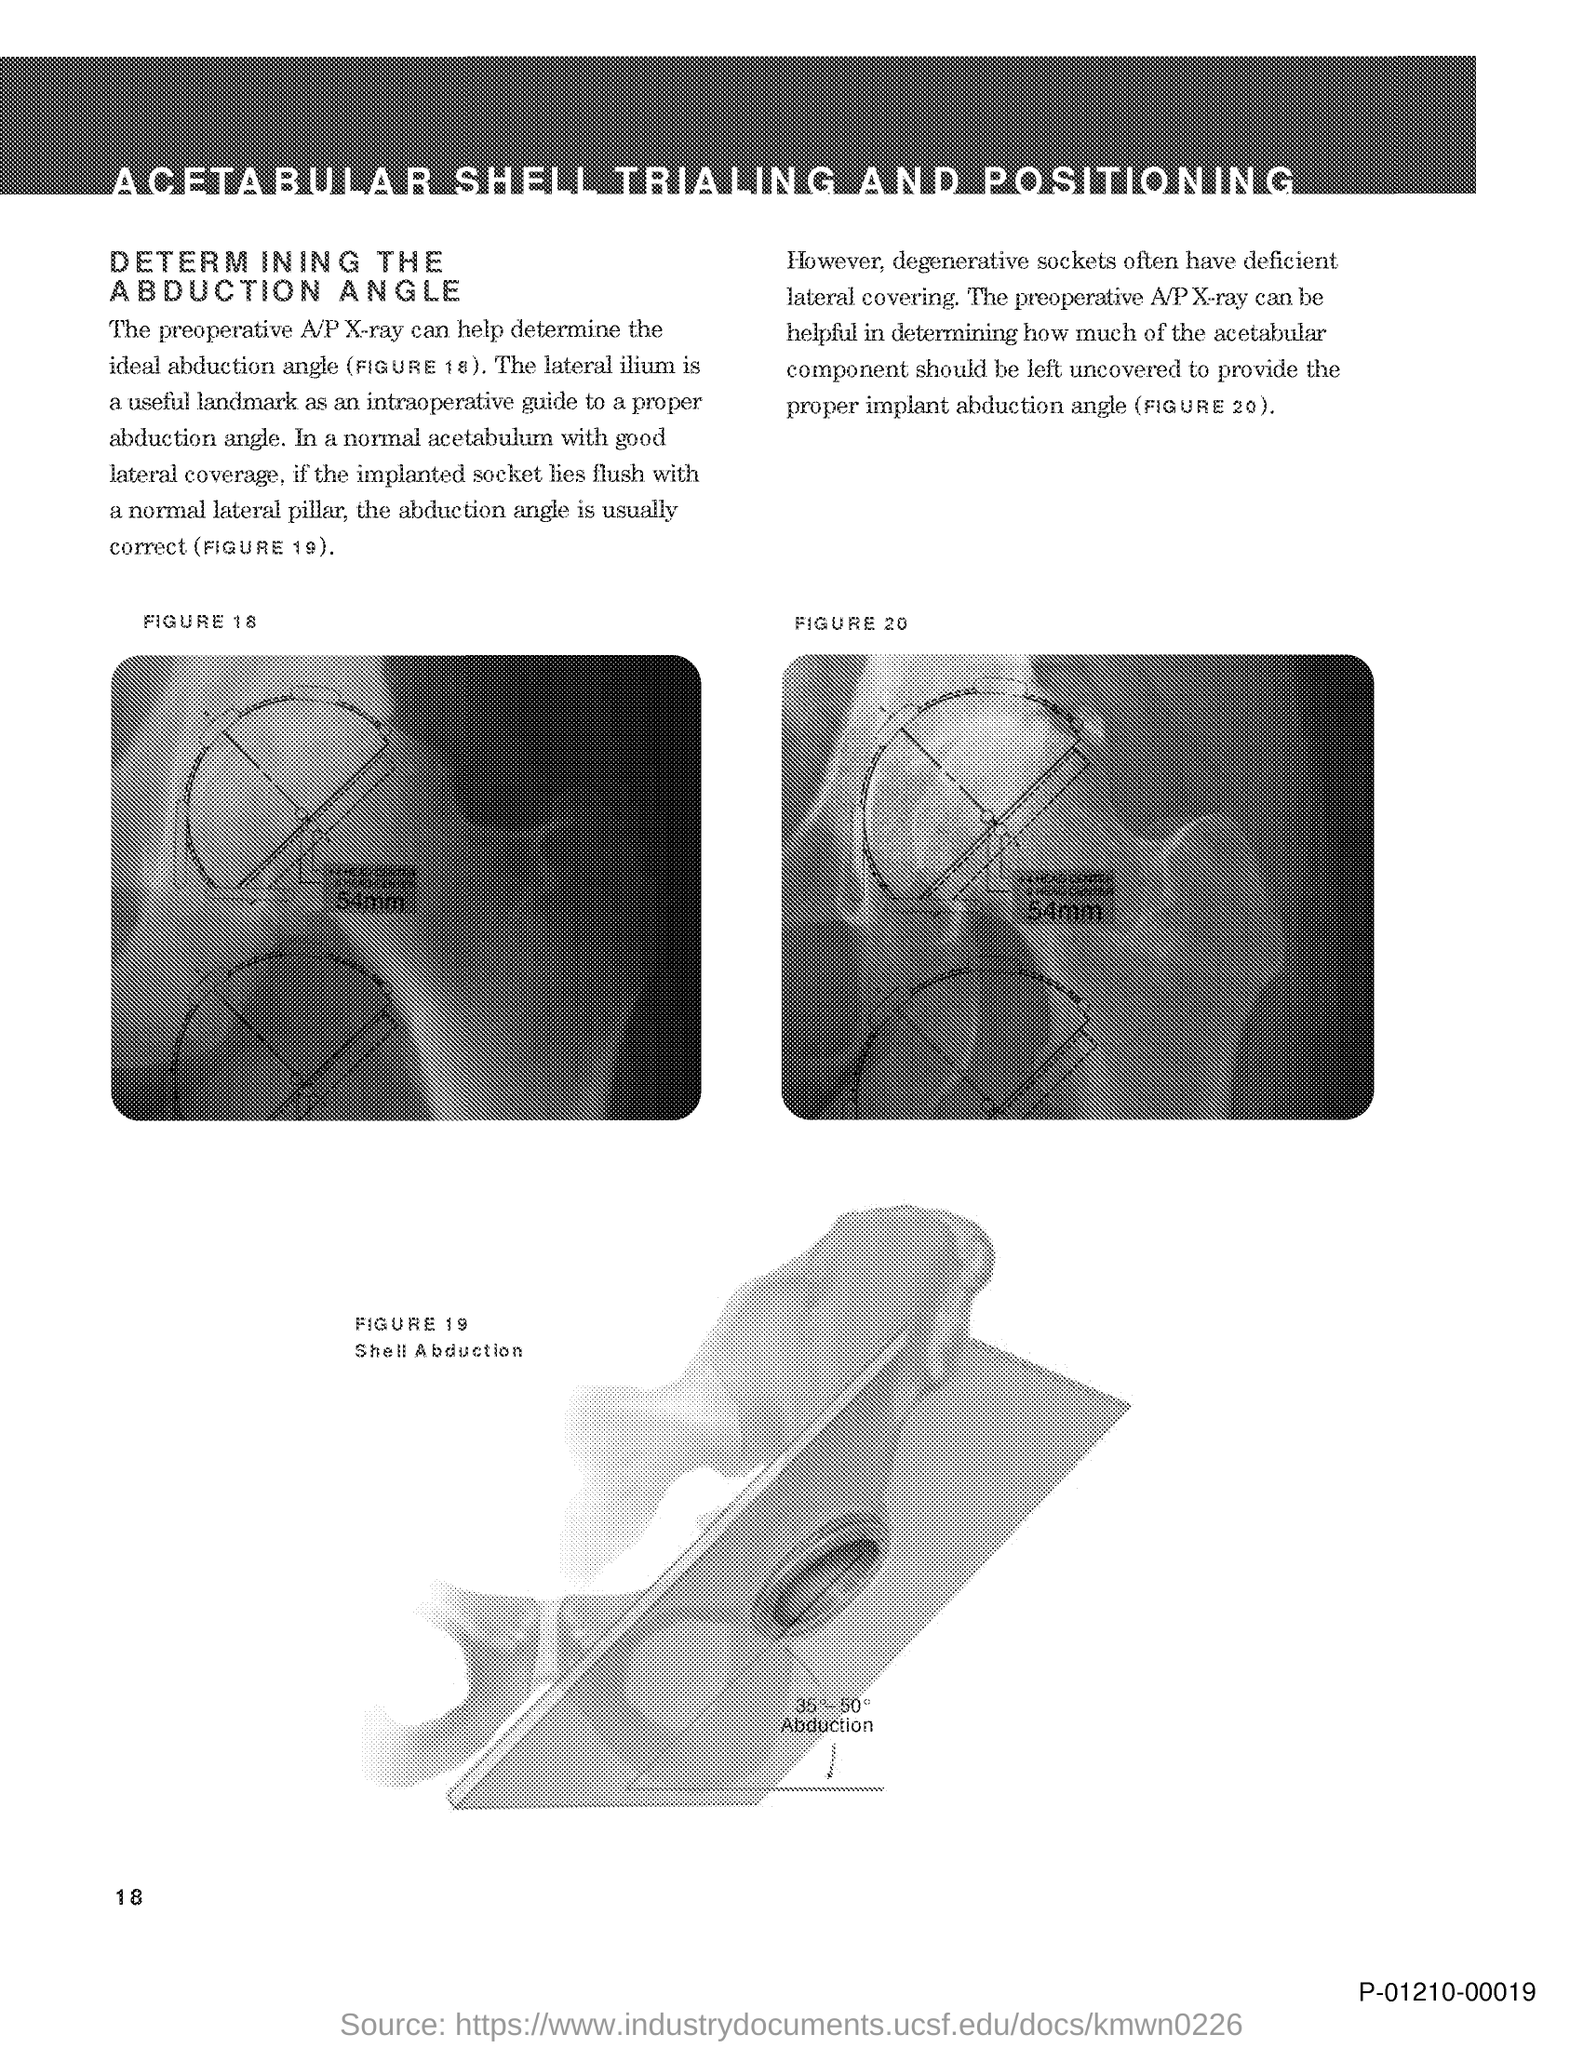What does FIGURE 19 in this document represent?
Provide a short and direct response. Shell Abduction. What is the page no mentioned in this document?
Keep it short and to the point. 18. Which X-ray can help to determine the ideal abduction angle?
Your answer should be very brief. Preoperative a/p x-ray. What is a useful landmark as an intraoperative guide to a proper abduction angle?
Provide a succinct answer. The lateral ilium. 